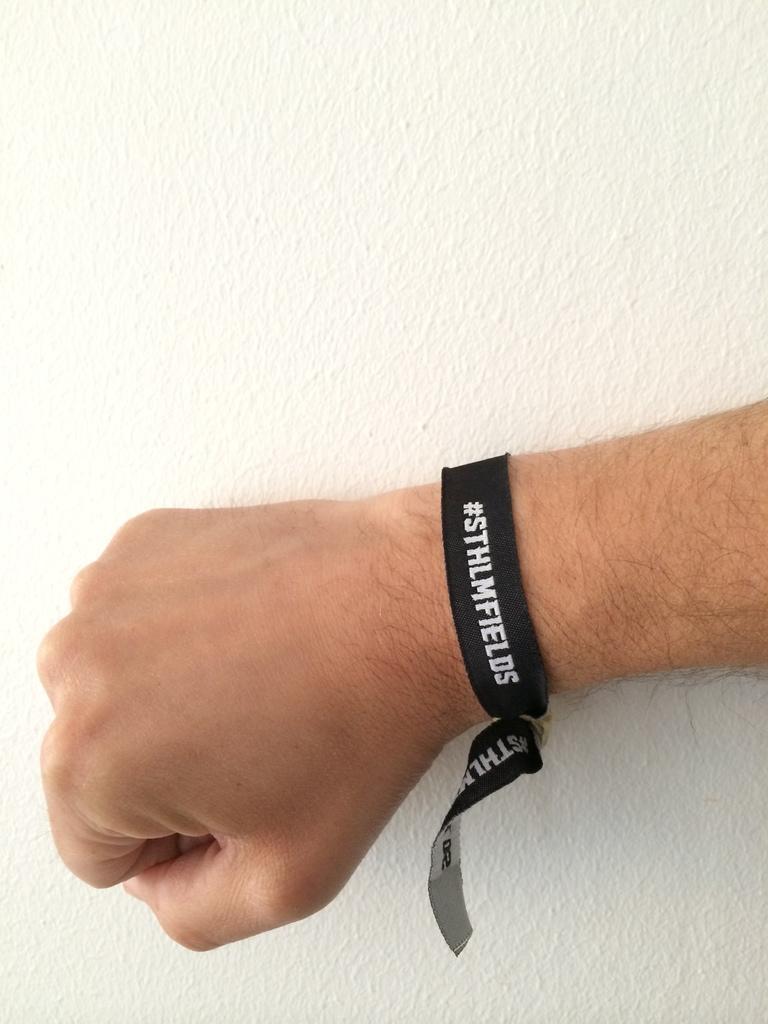Can you describe this image briefly? This picture is mainly highlighted with a human's hand. We can see a wristband tied over to the hand. On the background we can see a white colour and i guess it's a wall. 